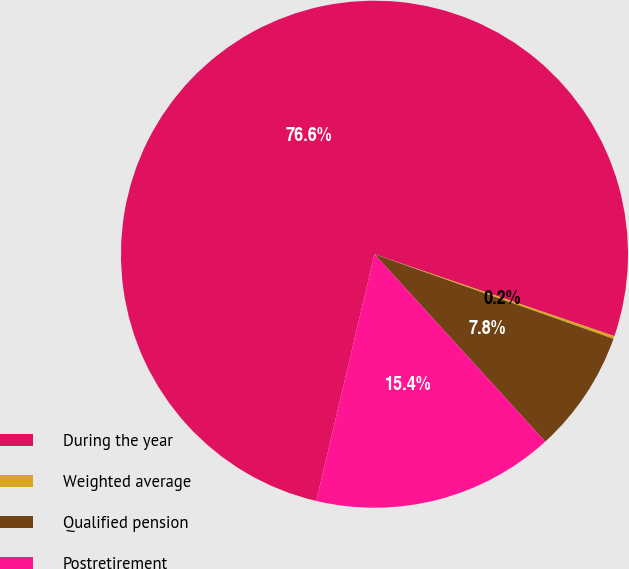Convert chart. <chart><loc_0><loc_0><loc_500><loc_500><pie_chart><fcel>During the year<fcel>Weighted average<fcel>Qualified pension<fcel>Postretirement<nl><fcel>76.55%<fcel>0.18%<fcel>7.82%<fcel>15.45%<nl></chart> 